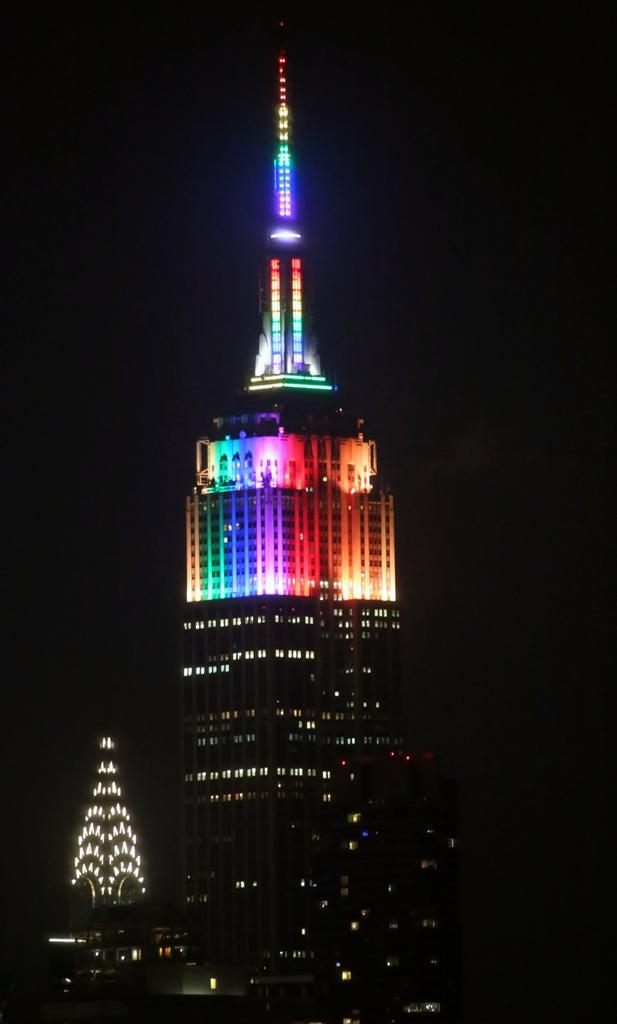What type of structures are present in the image? There are big buildings in the image. What distinguishes the appearance of the buildings? The buildings have different color lights. What part of the natural environment is visible in the image? The sky is visible in the image. What time of day is depicted in the image? The image is set during night time. Can you see any squirrels running on the wool in the image? There are no squirrels or wool present in the image. 